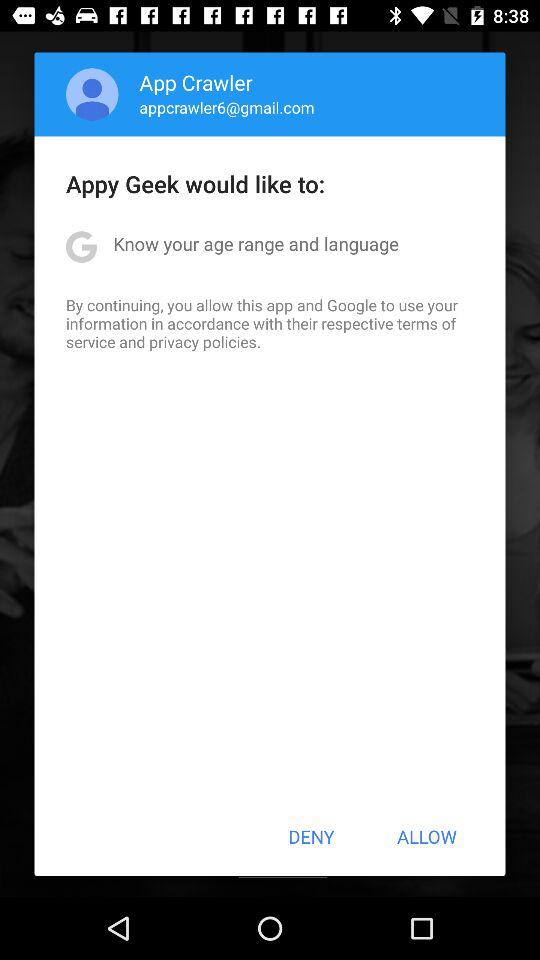What is the email address? The email address is appcrawler6@gmail.com. 